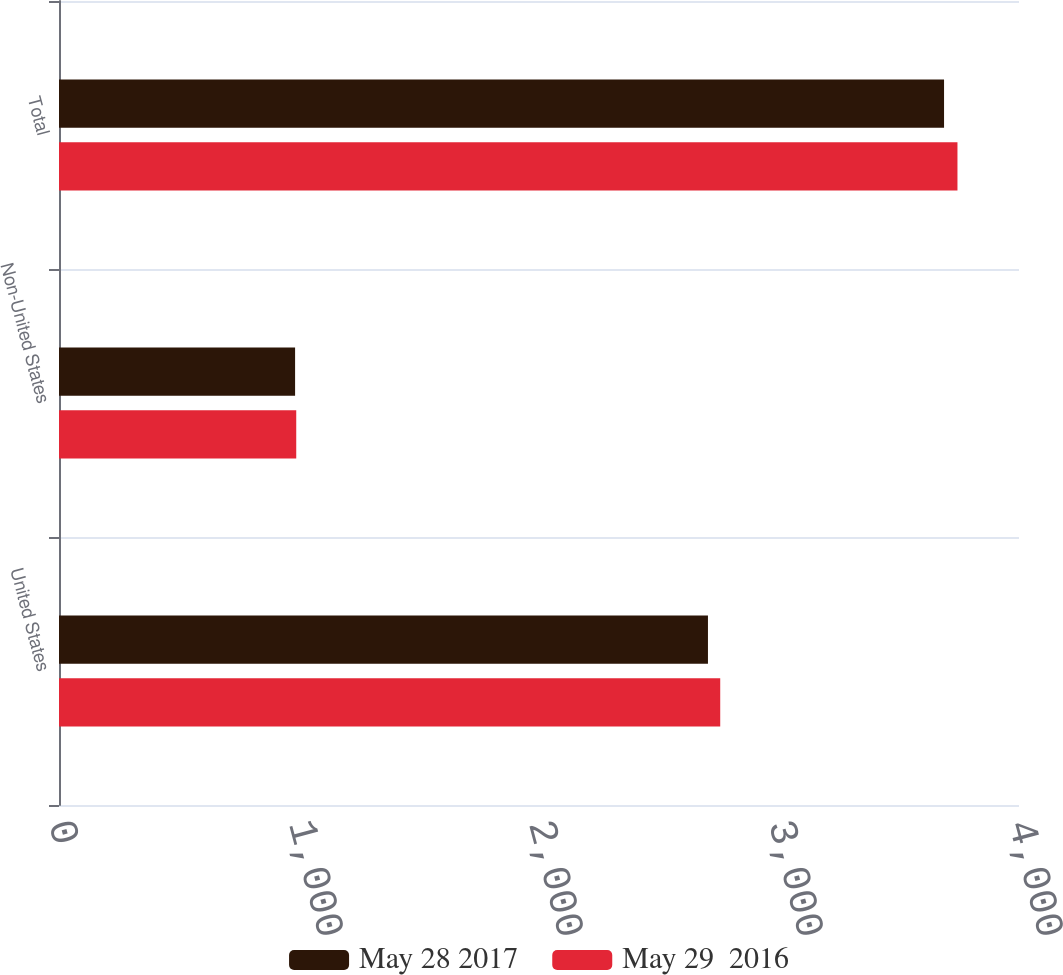Convert chart to OTSL. <chart><loc_0><loc_0><loc_500><loc_500><stacked_bar_chart><ecel><fcel>United States<fcel>Non-United States<fcel>Total<nl><fcel>May 28 2017<fcel>2704<fcel>983.7<fcel>3687.7<nl><fcel>May 29  2016<fcel>2755.1<fcel>988.5<fcel>3743.6<nl></chart> 